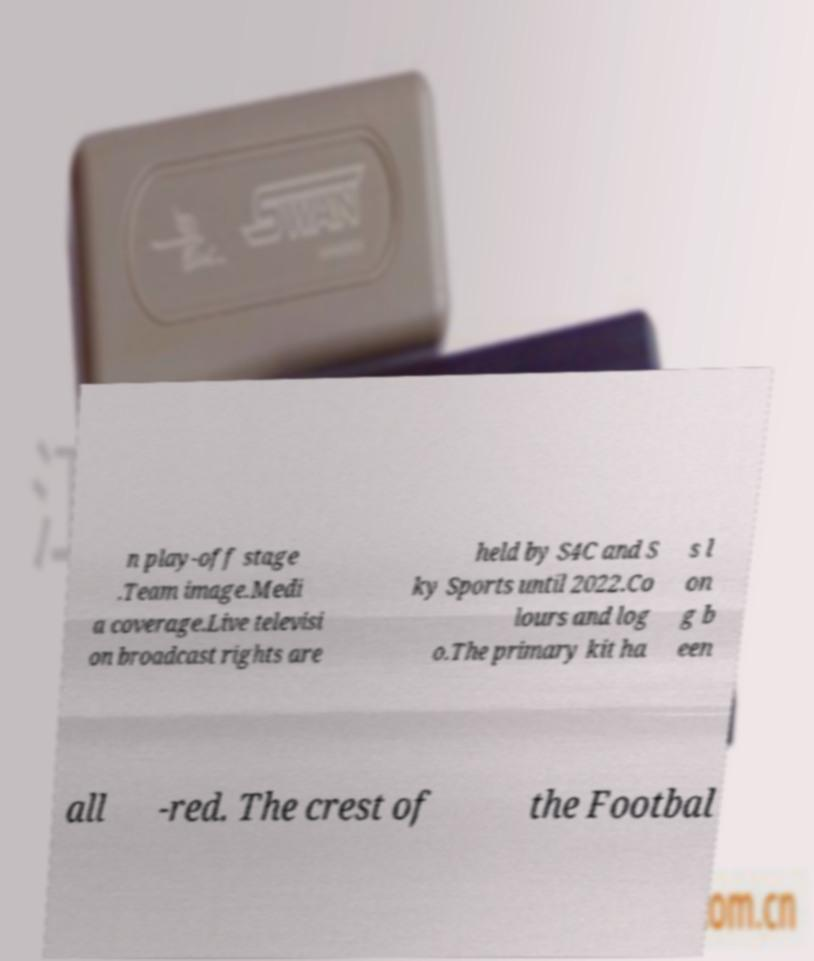Please read and relay the text visible in this image. What does it say? n play-off stage .Team image.Medi a coverage.Live televisi on broadcast rights are held by S4C and S ky Sports until 2022.Co lours and log o.The primary kit ha s l on g b een all -red. The crest of the Footbal 